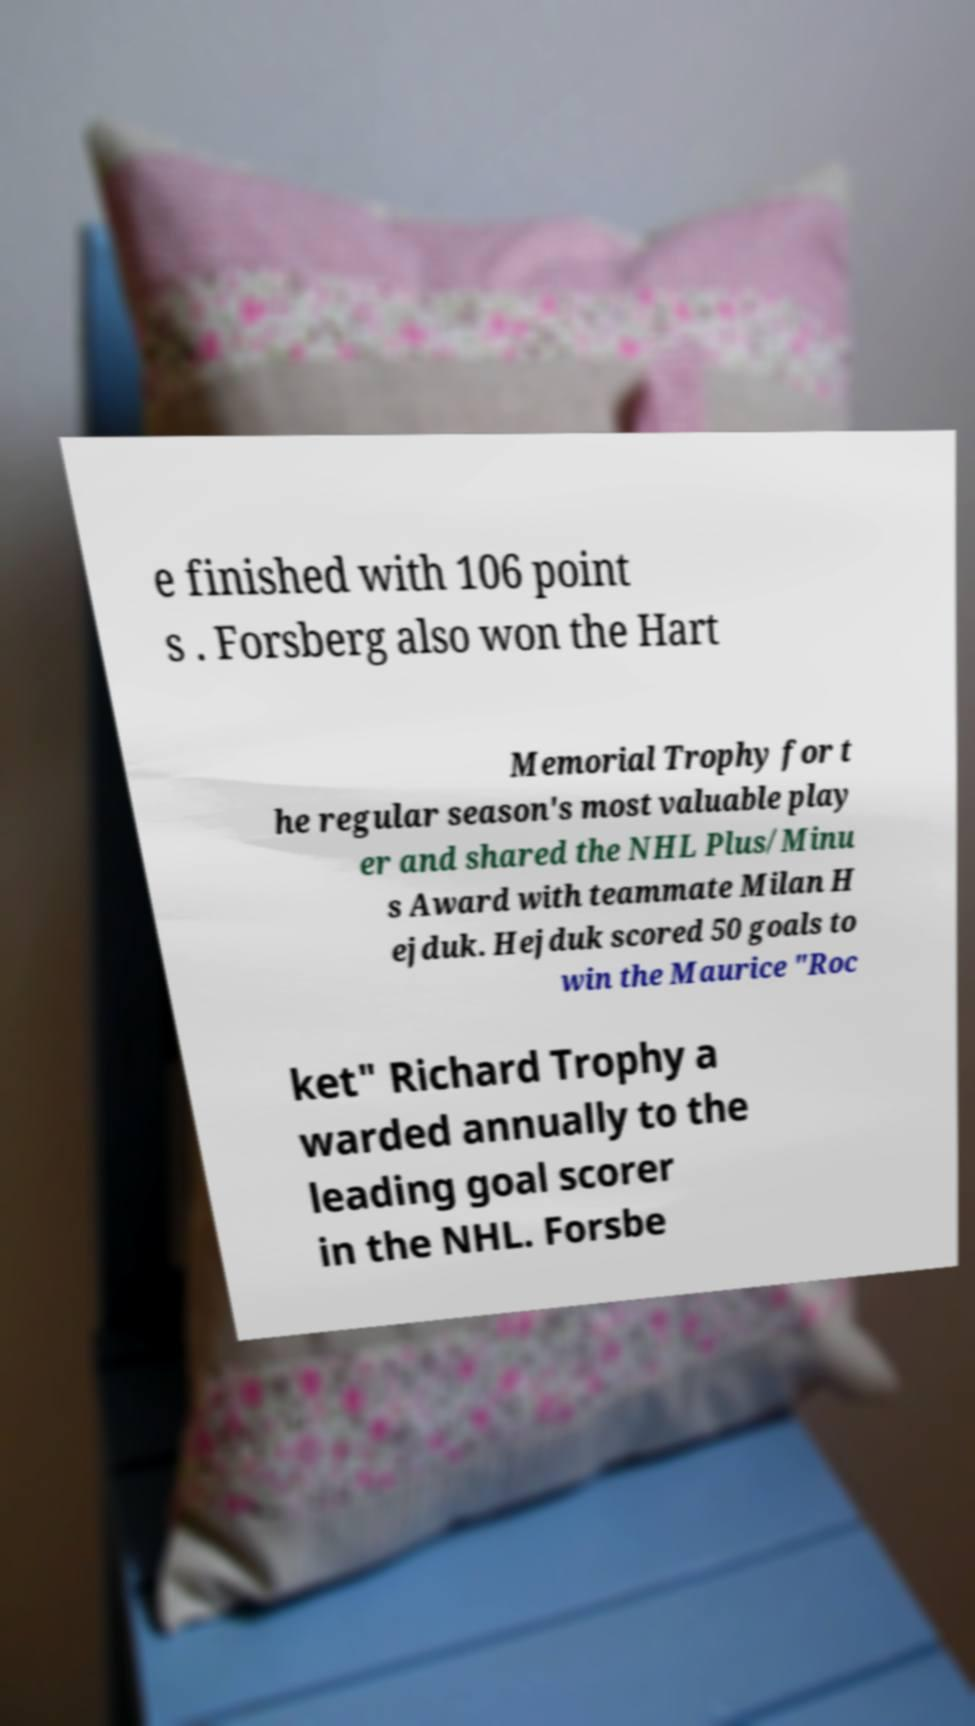Can you accurately transcribe the text from the provided image for me? e finished with 106 point s . Forsberg also won the Hart Memorial Trophy for t he regular season's most valuable play er and shared the NHL Plus/Minu s Award with teammate Milan H ejduk. Hejduk scored 50 goals to win the Maurice "Roc ket" Richard Trophy a warded annually to the leading goal scorer in the NHL. Forsbe 